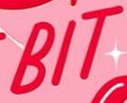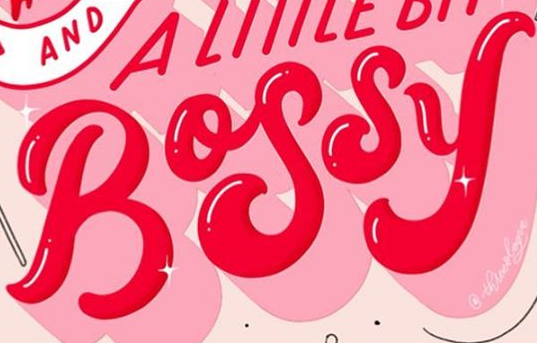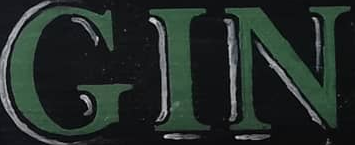Identify the words shown in these images in order, separated by a semicolon. BIT; BOSSY; GIN 